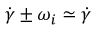<formula> <loc_0><loc_0><loc_500><loc_500>\dot { \gamma } \pm \omega _ { i } \simeq \dot { \gamma }</formula> 